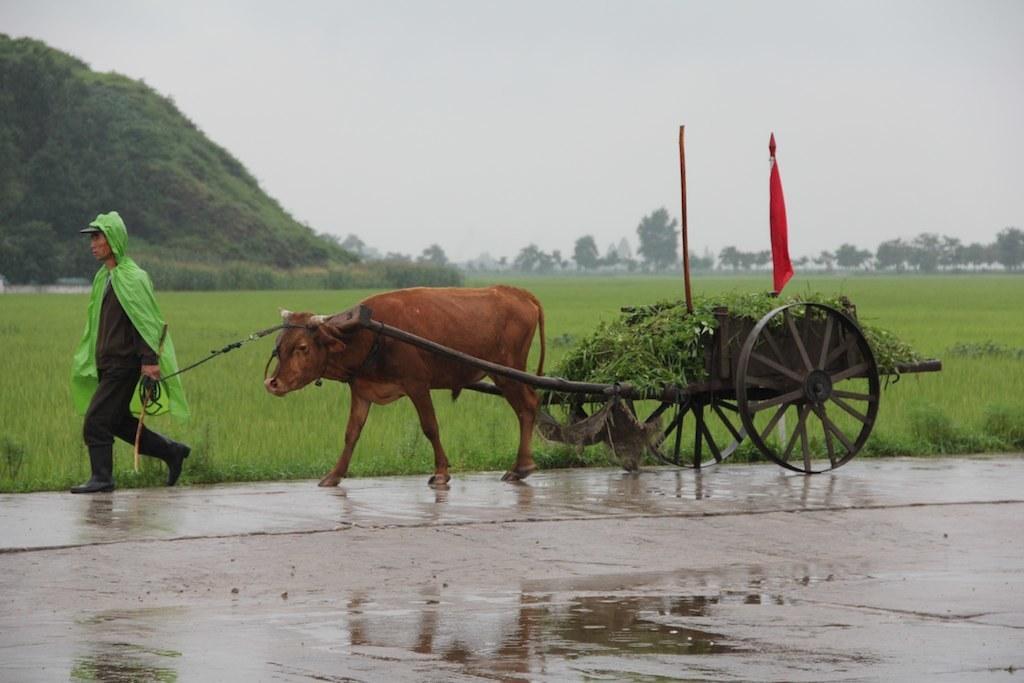Describe this image in one or two sentences. In the image there is a man carrying a bullock cart and on the cart there is some grass and the cart is tied to a cow and the ground is wet. Behind the ground there is a lot of greenery and in the background there is a mountain and sky. 